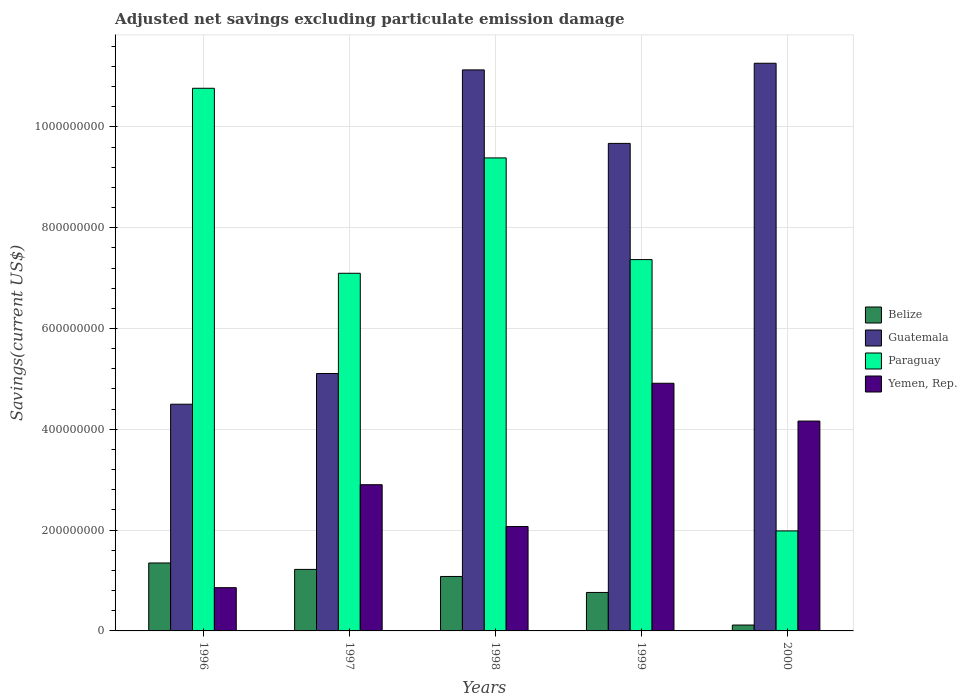How many groups of bars are there?
Offer a terse response. 5. Are the number of bars per tick equal to the number of legend labels?
Offer a terse response. Yes. How many bars are there on the 2nd tick from the left?
Your response must be concise. 4. How many bars are there on the 2nd tick from the right?
Keep it short and to the point. 4. What is the label of the 3rd group of bars from the left?
Keep it short and to the point. 1998. In how many cases, is the number of bars for a given year not equal to the number of legend labels?
Your response must be concise. 0. What is the adjusted net savings in Guatemala in 1999?
Your response must be concise. 9.67e+08. Across all years, what is the maximum adjusted net savings in Paraguay?
Keep it short and to the point. 1.08e+09. Across all years, what is the minimum adjusted net savings in Belize?
Ensure brevity in your answer.  1.17e+07. In which year was the adjusted net savings in Yemen, Rep. maximum?
Make the answer very short. 1999. What is the total adjusted net savings in Belize in the graph?
Keep it short and to the point. 4.53e+08. What is the difference between the adjusted net savings in Guatemala in 1996 and that in 1997?
Your answer should be compact. -6.09e+07. What is the difference between the adjusted net savings in Belize in 1998 and the adjusted net savings in Yemen, Rep. in 1996?
Offer a terse response. 2.22e+07. What is the average adjusted net savings in Guatemala per year?
Provide a succinct answer. 8.33e+08. In the year 2000, what is the difference between the adjusted net savings in Paraguay and adjusted net savings in Yemen, Rep.?
Ensure brevity in your answer.  -2.18e+08. In how many years, is the adjusted net savings in Guatemala greater than 1080000000 US$?
Ensure brevity in your answer.  2. What is the ratio of the adjusted net savings in Guatemala in 1998 to that in 2000?
Your answer should be very brief. 0.99. Is the adjusted net savings in Yemen, Rep. in 1997 less than that in 2000?
Provide a short and direct response. Yes. Is the difference between the adjusted net savings in Paraguay in 1996 and 2000 greater than the difference between the adjusted net savings in Yemen, Rep. in 1996 and 2000?
Make the answer very short. Yes. What is the difference between the highest and the second highest adjusted net savings in Yemen, Rep.?
Provide a succinct answer. 7.50e+07. What is the difference between the highest and the lowest adjusted net savings in Guatemala?
Provide a succinct answer. 6.76e+08. In how many years, is the adjusted net savings in Paraguay greater than the average adjusted net savings in Paraguay taken over all years?
Your response must be concise. 3. Is it the case that in every year, the sum of the adjusted net savings in Guatemala and adjusted net savings in Yemen, Rep. is greater than the sum of adjusted net savings in Belize and adjusted net savings in Paraguay?
Keep it short and to the point. Yes. What does the 3rd bar from the left in 1998 represents?
Your answer should be compact. Paraguay. What does the 2nd bar from the right in 1997 represents?
Provide a succinct answer. Paraguay. Are all the bars in the graph horizontal?
Make the answer very short. No. How many years are there in the graph?
Give a very brief answer. 5. Does the graph contain any zero values?
Your answer should be compact. No. Does the graph contain grids?
Offer a terse response. Yes. Where does the legend appear in the graph?
Make the answer very short. Center right. How are the legend labels stacked?
Give a very brief answer. Vertical. What is the title of the graph?
Provide a short and direct response. Adjusted net savings excluding particulate emission damage. What is the label or title of the X-axis?
Make the answer very short. Years. What is the label or title of the Y-axis?
Make the answer very short. Savings(current US$). What is the Savings(current US$) of Belize in 1996?
Offer a terse response. 1.35e+08. What is the Savings(current US$) in Guatemala in 1996?
Provide a succinct answer. 4.50e+08. What is the Savings(current US$) of Paraguay in 1996?
Provide a short and direct response. 1.08e+09. What is the Savings(current US$) in Yemen, Rep. in 1996?
Make the answer very short. 8.58e+07. What is the Savings(current US$) of Belize in 1997?
Give a very brief answer. 1.22e+08. What is the Savings(current US$) in Guatemala in 1997?
Provide a succinct answer. 5.11e+08. What is the Savings(current US$) in Paraguay in 1997?
Provide a short and direct response. 7.10e+08. What is the Savings(current US$) in Yemen, Rep. in 1997?
Keep it short and to the point. 2.90e+08. What is the Savings(current US$) of Belize in 1998?
Offer a very short reply. 1.08e+08. What is the Savings(current US$) of Guatemala in 1998?
Keep it short and to the point. 1.11e+09. What is the Savings(current US$) in Paraguay in 1998?
Provide a short and direct response. 9.38e+08. What is the Savings(current US$) of Yemen, Rep. in 1998?
Provide a succinct answer. 2.07e+08. What is the Savings(current US$) of Belize in 1999?
Your answer should be compact. 7.63e+07. What is the Savings(current US$) of Guatemala in 1999?
Give a very brief answer. 9.67e+08. What is the Savings(current US$) of Paraguay in 1999?
Provide a succinct answer. 7.37e+08. What is the Savings(current US$) of Yemen, Rep. in 1999?
Provide a succinct answer. 4.91e+08. What is the Savings(current US$) in Belize in 2000?
Offer a terse response. 1.17e+07. What is the Savings(current US$) of Guatemala in 2000?
Your answer should be very brief. 1.13e+09. What is the Savings(current US$) in Paraguay in 2000?
Your answer should be compact. 1.98e+08. What is the Savings(current US$) of Yemen, Rep. in 2000?
Provide a short and direct response. 4.16e+08. Across all years, what is the maximum Savings(current US$) in Belize?
Offer a very short reply. 1.35e+08. Across all years, what is the maximum Savings(current US$) in Guatemala?
Offer a terse response. 1.13e+09. Across all years, what is the maximum Savings(current US$) in Paraguay?
Offer a very short reply. 1.08e+09. Across all years, what is the maximum Savings(current US$) in Yemen, Rep.?
Your response must be concise. 4.91e+08. Across all years, what is the minimum Savings(current US$) in Belize?
Ensure brevity in your answer.  1.17e+07. Across all years, what is the minimum Savings(current US$) of Guatemala?
Ensure brevity in your answer.  4.50e+08. Across all years, what is the minimum Savings(current US$) of Paraguay?
Ensure brevity in your answer.  1.98e+08. Across all years, what is the minimum Savings(current US$) of Yemen, Rep.?
Your answer should be very brief. 8.58e+07. What is the total Savings(current US$) of Belize in the graph?
Make the answer very short. 4.53e+08. What is the total Savings(current US$) in Guatemala in the graph?
Keep it short and to the point. 4.17e+09. What is the total Savings(current US$) in Paraguay in the graph?
Your response must be concise. 3.66e+09. What is the total Savings(current US$) in Yemen, Rep. in the graph?
Provide a succinct answer. 1.49e+09. What is the difference between the Savings(current US$) of Belize in 1996 and that in 1997?
Keep it short and to the point. 1.27e+07. What is the difference between the Savings(current US$) in Guatemala in 1996 and that in 1997?
Keep it short and to the point. -6.09e+07. What is the difference between the Savings(current US$) in Paraguay in 1996 and that in 1997?
Offer a very short reply. 3.67e+08. What is the difference between the Savings(current US$) in Yemen, Rep. in 1996 and that in 1997?
Offer a terse response. -2.04e+08. What is the difference between the Savings(current US$) in Belize in 1996 and that in 1998?
Ensure brevity in your answer.  2.68e+07. What is the difference between the Savings(current US$) in Guatemala in 1996 and that in 1998?
Offer a very short reply. -6.63e+08. What is the difference between the Savings(current US$) of Paraguay in 1996 and that in 1998?
Your response must be concise. 1.38e+08. What is the difference between the Savings(current US$) in Yemen, Rep. in 1996 and that in 1998?
Ensure brevity in your answer.  -1.21e+08. What is the difference between the Savings(current US$) in Belize in 1996 and that in 1999?
Provide a short and direct response. 5.85e+07. What is the difference between the Savings(current US$) of Guatemala in 1996 and that in 1999?
Give a very brief answer. -5.17e+08. What is the difference between the Savings(current US$) of Paraguay in 1996 and that in 1999?
Your answer should be very brief. 3.40e+08. What is the difference between the Savings(current US$) in Yemen, Rep. in 1996 and that in 1999?
Offer a very short reply. -4.06e+08. What is the difference between the Savings(current US$) in Belize in 1996 and that in 2000?
Offer a terse response. 1.23e+08. What is the difference between the Savings(current US$) of Guatemala in 1996 and that in 2000?
Your answer should be compact. -6.76e+08. What is the difference between the Savings(current US$) of Paraguay in 1996 and that in 2000?
Your answer should be very brief. 8.78e+08. What is the difference between the Savings(current US$) of Yemen, Rep. in 1996 and that in 2000?
Ensure brevity in your answer.  -3.31e+08. What is the difference between the Savings(current US$) of Belize in 1997 and that in 1998?
Provide a short and direct response. 1.40e+07. What is the difference between the Savings(current US$) in Guatemala in 1997 and that in 1998?
Your answer should be compact. -6.02e+08. What is the difference between the Savings(current US$) of Paraguay in 1997 and that in 1998?
Keep it short and to the point. -2.29e+08. What is the difference between the Savings(current US$) in Yemen, Rep. in 1997 and that in 1998?
Keep it short and to the point. 8.30e+07. What is the difference between the Savings(current US$) in Belize in 1997 and that in 1999?
Keep it short and to the point. 4.57e+07. What is the difference between the Savings(current US$) of Guatemala in 1997 and that in 1999?
Your answer should be compact. -4.57e+08. What is the difference between the Savings(current US$) of Paraguay in 1997 and that in 1999?
Offer a terse response. -2.71e+07. What is the difference between the Savings(current US$) of Yemen, Rep. in 1997 and that in 1999?
Ensure brevity in your answer.  -2.01e+08. What is the difference between the Savings(current US$) of Belize in 1997 and that in 2000?
Your answer should be very brief. 1.10e+08. What is the difference between the Savings(current US$) of Guatemala in 1997 and that in 2000?
Give a very brief answer. -6.16e+08. What is the difference between the Savings(current US$) of Paraguay in 1997 and that in 2000?
Your answer should be very brief. 5.11e+08. What is the difference between the Savings(current US$) of Yemen, Rep. in 1997 and that in 2000?
Your answer should be very brief. -1.26e+08. What is the difference between the Savings(current US$) in Belize in 1998 and that in 1999?
Provide a short and direct response. 3.17e+07. What is the difference between the Savings(current US$) of Guatemala in 1998 and that in 1999?
Your answer should be compact. 1.46e+08. What is the difference between the Savings(current US$) of Paraguay in 1998 and that in 1999?
Offer a terse response. 2.02e+08. What is the difference between the Savings(current US$) of Yemen, Rep. in 1998 and that in 1999?
Make the answer very short. -2.84e+08. What is the difference between the Savings(current US$) of Belize in 1998 and that in 2000?
Your response must be concise. 9.64e+07. What is the difference between the Savings(current US$) in Guatemala in 1998 and that in 2000?
Offer a terse response. -1.32e+07. What is the difference between the Savings(current US$) of Paraguay in 1998 and that in 2000?
Your answer should be compact. 7.40e+08. What is the difference between the Savings(current US$) in Yemen, Rep. in 1998 and that in 2000?
Provide a succinct answer. -2.09e+08. What is the difference between the Savings(current US$) in Belize in 1999 and that in 2000?
Your answer should be compact. 6.47e+07. What is the difference between the Savings(current US$) in Guatemala in 1999 and that in 2000?
Make the answer very short. -1.59e+08. What is the difference between the Savings(current US$) in Paraguay in 1999 and that in 2000?
Your answer should be compact. 5.38e+08. What is the difference between the Savings(current US$) in Yemen, Rep. in 1999 and that in 2000?
Your answer should be compact. 7.50e+07. What is the difference between the Savings(current US$) of Belize in 1996 and the Savings(current US$) of Guatemala in 1997?
Offer a very short reply. -3.76e+08. What is the difference between the Savings(current US$) of Belize in 1996 and the Savings(current US$) of Paraguay in 1997?
Your response must be concise. -5.75e+08. What is the difference between the Savings(current US$) of Belize in 1996 and the Savings(current US$) of Yemen, Rep. in 1997?
Your response must be concise. -1.55e+08. What is the difference between the Savings(current US$) in Guatemala in 1996 and the Savings(current US$) in Paraguay in 1997?
Keep it short and to the point. -2.60e+08. What is the difference between the Savings(current US$) of Guatemala in 1996 and the Savings(current US$) of Yemen, Rep. in 1997?
Offer a very short reply. 1.60e+08. What is the difference between the Savings(current US$) in Paraguay in 1996 and the Savings(current US$) in Yemen, Rep. in 1997?
Keep it short and to the point. 7.87e+08. What is the difference between the Savings(current US$) of Belize in 1996 and the Savings(current US$) of Guatemala in 1998?
Give a very brief answer. -9.78e+08. What is the difference between the Savings(current US$) of Belize in 1996 and the Savings(current US$) of Paraguay in 1998?
Offer a very short reply. -8.04e+08. What is the difference between the Savings(current US$) of Belize in 1996 and the Savings(current US$) of Yemen, Rep. in 1998?
Your answer should be very brief. -7.23e+07. What is the difference between the Savings(current US$) of Guatemala in 1996 and the Savings(current US$) of Paraguay in 1998?
Provide a succinct answer. -4.89e+08. What is the difference between the Savings(current US$) in Guatemala in 1996 and the Savings(current US$) in Yemen, Rep. in 1998?
Ensure brevity in your answer.  2.43e+08. What is the difference between the Savings(current US$) of Paraguay in 1996 and the Savings(current US$) of Yemen, Rep. in 1998?
Your answer should be compact. 8.70e+08. What is the difference between the Savings(current US$) of Belize in 1996 and the Savings(current US$) of Guatemala in 1999?
Give a very brief answer. -8.32e+08. What is the difference between the Savings(current US$) of Belize in 1996 and the Savings(current US$) of Paraguay in 1999?
Your response must be concise. -6.02e+08. What is the difference between the Savings(current US$) of Belize in 1996 and the Savings(current US$) of Yemen, Rep. in 1999?
Your answer should be very brief. -3.57e+08. What is the difference between the Savings(current US$) in Guatemala in 1996 and the Savings(current US$) in Paraguay in 1999?
Your response must be concise. -2.87e+08. What is the difference between the Savings(current US$) in Guatemala in 1996 and the Savings(current US$) in Yemen, Rep. in 1999?
Ensure brevity in your answer.  -4.16e+07. What is the difference between the Savings(current US$) of Paraguay in 1996 and the Savings(current US$) of Yemen, Rep. in 1999?
Provide a succinct answer. 5.85e+08. What is the difference between the Savings(current US$) in Belize in 1996 and the Savings(current US$) in Guatemala in 2000?
Offer a very short reply. -9.91e+08. What is the difference between the Savings(current US$) in Belize in 1996 and the Savings(current US$) in Paraguay in 2000?
Keep it short and to the point. -6.36e+07. What is the difference between the Savings(current US$) of Belize in 1996 and the Savings(current US$) of Yemen, Rep. in 2000?
Keep it short and to the point. -2.82e+08. What is the difference between the Savings(current US$) of Guatemala in 1996 and the Savings(current US$) of Paraguay in 2000?
Provide a short and direct response. 2.51e+08. What is the difference between the Savings(current US$) of Guatemala in 1996 and the Savings(current US$) of Yemen, Rep. in 2000?
Keep it short and to the point. 3.34e+07. What is the difference between the Savings(current US$) of Paraguay in 1996 and the Savings(current US$) of Yemen, Rep. in 2000?
Offer a very short reply. 6.60e+08. What is the difference between the Savings(current US$) in Belize in 1997 and the Savings(current US$) in Guatemala in 1998?
Provide a succinct answer. -9.91e+08. What is the difference between the Savings(current US$) of Belize in 1997 and the Savings(current US$) of Paraguay in 1998?
Provide a succinct answer. -8.16e+08. What is the difference between the Savings(current US$) in Belize in 1997 and the Savings(current US$) in Yemen, Rep. in 1998?
Your answer should be compact. -8.50e+07. What is the difference between the Savings(current US$) in Guatemala in 1997 and the Savings(current US$) in Paraguay in 1998?
Your answer should be very brief. -4.28e+08. What is the difference between the Savings(current US$) of Guatemala in 1997 and the Savings(current US$) of Yemen, Rep. in 1998?
Provide a short and direct response. 3.04e+08. What is the difference between the Savings(current US$) in Paraguay in 1997 and the Savings(current US$) in Yemen, Rep. in 1998?
Offer a very short reply. 5.02e+08. What is the difference between the Savings(current US$) in Belize in 1997 and the Savings(current US$) in Guatemala in 1999?
Your response must be concise. -8.45e+08. What is the difference between the Savings(current US$) of Belize in 1997 and the Savings(current US$) of Paraguay in 1999?
Your answer should be very brief. -6.15e+08. What is the difference between the Savings(current US$) of Belize in 1997 and the Savings(current US$) of Yemen, Rep. in 1999?
Your answer should be very brief. -3.69e+08. What is the difference between the Savings(current US$) of Guatemala in 1997 and the Savings(current US$) of Paraguay in 1999?
Your response must be concise. -2.26e+08. What is the difference between the Savings(current US$) of Guatemala in 1997 and the Savings(current US$) of Yemen, Rep. in 1999?
Give a very brief answer. 1.93e+07. What is the difference between the Savings(current US$) in Paraguay in 1997 and the Savings(current US$) in Yemen, Rep. in 1999?
Offer a terse response. 2.18e+08. What is the difference between the Savings(current US$) of Belize in 1997 and the Savings(current US$) of Guatemala in 2000?
Your answer should be compact. -1.00e+09. What is the difference between the Savings(current US$) in Belize in 1997 and the Savings(current US$) in Paraguay in 2000?
Offer a very short reply. -7.64e+07. What is the difference between the Savings(current US$) in Belize in 1997 and the Savings(current US$) in Yemen, Rep. in 2000?
Provide a short and direct response. -2.94e+08. What is the difference between the Savings(current US$) in Guatemala in 1997 and the Savings(current US$) in Paraguay in 2000?
Provide a succinct answer. 3.12e+08. What is the difference between the Savings(current US$) in Guatemala in 1997 and the Savings(current US$) in Yemen, Rep. in 2000?
Ensure brevity in your answer.  9.43e+07. What is the difference between the Savings(current US$) in Paraguay in 1997 and the Savings(current US$) in Yemen, Rep. in 2000?
Provide a short and direct response. 2.93e+08. What is the difference between the Savings(current US$) in Belize in 1998 and the Savings(current US$) in Guatemala in 1999?
Give a very brief answer. -8.59e+08. What is the difference between the Savings(current US$) in Belize in 1998 and the Savings(current US$) in Paraguay in 1999?
Provide a succinct answer. -6.29e+08. What is the difference between the Savings(current US$) of Belize in 1998 and the Savings(current US$) of Yemen, Rep. in 1999?
Your answer should be very brief. -3.83e+08. What is the difference between the Savings(current US$) of Guatemala in 1998 and the Savings(current US$) of Paraguay in 1999?
Give a very brief answer. 3.76e+08. What is the difference between the Savings(current US$) of Guatemala in 1998 and the Savings(current US$) of Yemen, Rep. in 1999?
Keep it short and to the point. 6.22e+08. What is the difference between the Savings(current US$) of Paraguay in 1998 and the Savings(current US$) of Yemen, Rep. in 1999?
Keep it short and to the point. 4.47e+08. What is the difference between the Savings(current US$) in Belize in 1998 and the Savings(current US$) in Guatemala in 2000?
Offer a very short reply. -1.02e+09. What is the difference between the Savings(current US$) of Belize in 1998 and the Savings(current US$) of Paraguay in 2000?
Give a very brief answer. -9.04e+07. What is the difference between the Savings(current US$) of Belize in 1998 and the Savings(current US$) of Yemen, Rep. in 2000?
Make the answer very short. -3.08e+08. What is the difference between the Savings(current US$) of Guatemala in 1998 and the Savings(current US$) of Paraguay in 2000?
Your answer should be very brief. 9.15e+08. What is the difference between the Savings(current US$) in Guatemala in 1998 and the Savings(current US$) in Yemen, Rep. in 2000?
Your answer should be compact. 6.97e+08. What is the difference between the Savings(current US$) in Paraguay in 1998 and the Savings(current US$) in Yemen, Rep. in 2000?
Provide a short and direct response. 5.22e+08. What is the difference between the Savings(current US$) of Belize in 1999 and the Savings(current US$) of Guatemala in 2000?
Your answer should be compact. -1.05e+09. What is the difference between the Savings(current US$) of Belize in 1999 and the Savings(current US$) of Paraguay in 2000?
Provide a short and direct response. -1.22e+08. What is the difference between the Savings(current US$) in Belize in 1999 and the Savings(current US$) in Yemen, Rep. in 2000?
Make the answer very short. -3.40e+08. What is the difference between the Savings(current US$) of Guatemala in 1999 and the Savings(current US$) of Paraguay in 2000?
Your response must be concise. 7.69e+08. What is the difference between the Savings(current US$) of Guatemala in 1999 and the Savings(current US$) of Yemen, Rep. in 2000?
Provide a succinct answer. 5.51e+08. What is the difference between the Savings(current US$) in Paraguay in 1999 and the Savings(current US$) in Yemen, Rep. in 2000?
Your answer should be very brief. 3.20e+08. What is the average Savings(current US$) of Belize per year?
Ensure brevity in your answer.  9.06e+07. What is the average Savings(current US$) of Guatemala per year?
Your answer should be compact. 8.33e+08. What is the average Savings(current US$) of Paraguay per year?
Make the answer very short. 7.32e+08. What is the average Savings(current US$) of Yemen, Rep. per year?
Your answer should be very brief. 2.98e+08. In the year 1996, what is the difference between the Savings(current US$) of Belize and Savings(current US$) of Guatemala?
Your answer should be very brief. -3.15e+08. In the year 1996, what is the difference between the Savings(current US$) in Belize and Savings(current US$) in Paraguay?
Your answer should be very brief. -9.42e+08. In the year 1996, what is the difference between the Savings(current US$) in Belize and Savings(current US$) in Yemen, Rep.?
Provide a short and direct response. 4.90e+07. In the year 1996, what is the difference between the Savings(current US$) of Guatemala and Savings(current US$) of Paraguay?
Provide a succinct answer. -6.27e+08. In the year 1996, what is the difference between the Savings(current US$) of Guatemala and Savings(current US$) of Yemen, Rep.?
Offer a very short reply. 3.64e+08. In the year 1996, what is the difference between the Savings(current US$) in Paraguay and Savings(current US$) in Yemen, Rep.?
Ensure brevity in your answer.  9.91e+08. In the year 1997, what is the difference between the Savings(current US$) of Belize and Savings(current US$) of Guatemala?
Give a very brief answer. -3.89e+08. In the year 1997, what is the difference between the Savings(current US$) in Belize and Savings(current US$) in Paraguay?
Keep it short and to the point. -5.88e+08. In the year 1997, what is the difference between the Savings(current US$) of Belize and Savings(current US$) of Yemen, Rep.?
Provide a short and direct response. -1.68e+08. In the year 1997, what is the difference between the Savings(current US$) in Guatemala and Savings(current US$) in Paraguay?
Ensure brevity in your answer.  -1.99e+08. In the year 1997, what is the difference between the Savings(current US$) in Guatemala and Savings(current US$) in Yemen, Rep.?
Keep it short and to the point. 2.21e+08. In the year 1997, what is the difference between the Savings(current US$) in Paraguay and Savings(current US$) in Yemen, Rep.?
Provide a short and direct response. 4.20e+08. In the year 1998, what is the difference between the Savings(current US$) in Belize and Savings(current US$) in Guatemala?
Your answer should be compact. -1.01e+09. In the year 1998, what is the difference between the Savings(current US$) of Belize and Savings(current US$) of Paraguay?
Provide a short and direct response. -8.30e+08. In the year 1998, what is the difference between the Savings(current US$) of Belize and Savings(current US$) of Yemen, Rep.?
Keep it short and to the point. -9.91e+07. In the year 1998, what is the difference between the Savings(current US$) in Guatemala and Savings(current US$) in Paraguay?
Offer a very short reply. 1.75e+08. In the year 1998, what is the difference between the Savings(current US$) of Guatemala and Savings(current US$) of Yemen, Rep.?
Offer a terse response. 9.06e+08. In the year 1998, what is the difference between the Savings(current US$) of Paraguay and Savings(current US$) of Yemen, Rep.?
Provide a succinct answer. 7.31e+08. In the year 1999, what is the difference between the Savings(current US$) in Belize and Savings(current US$) in Guatemala?
Offer a terse response. -8.91e+08. In the year 1999, what is the difference between the Savings(current US$) of Belize and Savings(current US$) of Paraguay?
Offer a terse response. -6.60e+08. In the year 1999, what is the difference between the Savings(current US$) in Belize and Savings(current US$) in Yemen, Rep.?
Ensure brevity in your answer.  -4.15e+08. In the year 1999, what is the difference between the Savings(current US$) of Guatemala and Savings(current US$) of Paraguay?
Offer a very short reply. 2.31e+08. In the year 1999, what is the difference between the Savings(current US$) in Guatemala and Savings(current US$) in Yemen, Rep.?
Offer a terse response. 4.76e+08. In the year 1999, what is the difference between the Savings(current US$) of Paraguay and Savings(current US$) of Yemen, Rep.?
Your answer should be compact. 2.45e+08. In the year 2000, what is the difference between the Savings(current US$) of Belize and Savings(current US$) of Guatemala?
Offer a terse response. -1.11e+09. In the year 2000, what is the difference between the Savings(current US$) of Belize and Savings(current US$) of Paraguay?
Ensure brevity in your answer.  -1.87e+08. In the year 2000, what is the difference between the Savings(current US$) in Belize and Savings(current US$) in Yemen, Rep.?
Offer a very short reply. -4.05e+08. In the year 2000, what is the difference between the Savings(current US$) in Guatemala and Savings(current US$) in Paraguay?
Make the answer very short. 9.28e+08. In the year 2000, what is the difference between the Savings(current US$) of Guatemala and Savings(current US$) of Yemen, Rep.?
Keep it short and to the point. 7.10e+08. In the year 2000, what is the difference between the Savings(current US$) of Paraguay and Savings(current US$) of Yemen, Rep.?
Your answer should be compact. -2.18e+08. What is the ratio of the Savings(current US$) of Belize in 1996 to that in 1997?
Ensure brevity in your answer.  1.1. What is the ratio of the Savings(current US$) of Guatemala in 1996 to that in 1997?
Offer a terse response. 0.88. What is the ratio of the Savings(current US$) of Paraguay in 1996 to that in 1997?
Your answer should be compact. 1.52. What is the ratio of the Savings(current US$) in Yemen, Rep. in 1996 to that in 1997?
Keep it short and to the point. 0.3. What is the ratio of the Savings(current US$) of Belize in 1996 to that in 1998?
Give a very brief answer. 1.25. What is the ratio of the Savings(current US$) of Guatemala in 1996 to that in 1998?
Your response must be concise. 0.4. What is the ratio of the Savings(current US$) in Paraguay in 1996 to that in 1998?
Your answer should be very brief. 1.15. What is the ratio of the Savings(current US$) of Yemen, Rep. in 1996 to that in 1998?
Offer a very short reply. 0.41. What is the ratio of the Savings(current US$) of Belize in 1996 to that in 1999?
Give a very brief answer. 1.77. What is the ratio of the Savings(current US$) in Guatemala in 1996 to that in 1999?
Your answer should be compact. 0.47. What is the ratio of the Savings(current US$) of Paraguay in 1996 to that in 1999?
Your response must be concise. 1.46. What is the ratio of the Savings(current US$) in Yemen, Rep. in 1996 to that in 1999?
Give a very brief answer. 0.17. What is the ratio of the Savings(current US$) of Belize in 1996 to that in 2000?
Offer a terse response. 11.54. What is the ratio of the Savings(current US$) in Guatemala in 1996 to that in 2000?
Make the answer very short. 0.4. What is the ratio of the Savings(current US$) of Paraguay in 1996 to that in 2000?
Provide a succinct answer. 5.43. What is the ratio of the Savings(current US$) of Yemen, Rep. in 1996 to that in 2000?
Offer a terse response. 0.21. What is the ratio of the Savings(current US$) of Belize in 1997 to that in 1998?
Make the answer very short. 1.13. What is the ratio of the Savings(current US$) of Guatemala in 1997 to that in 1998?
Keep it short and to the point. 0.46. What is the ratio of the Savings(current US$) in Paraguay in 1997 to that in 1998?
Your response must be concise. 0.76. What is the ratio of the Savings(current US$) in Yemen, Rep. in 1997 to that in 1998?
Give a very brief answer. 1.4. What is the ratio of the Savings(current US$) in Belize in 1997 to that in 1999?
Give a very brief answer. 1.6. What is the ratio of the Savings(current US$) in Guatemala in 1997 to that in 1999?
Offer a very short reply. 0.53. What is the ratio of the Savings(current US$) in Paraguay in 1997 to that in 1999?
Keep it short and to the point. 0.96. What is the ratio of the Savings(current US$) of Yemen, Rep. in 1997 to that in 1999?
Offer a terse response. 0.59. What is the ratio of the Savings(current US$) in Belize in 1997 to that in 2000?
Your response must be concise. 10.45. What is the ratio of the Savings(current US$) of Guatemala in 1997 to that in 2000?
Make the answer very short. 0.45. What is the ratio of the Savings(current US$) in Paraguay in 1997 to that in 2000?
Provide a succinct answer. 3.58. What is the ratio of the Savings(current US$) of Yemen, Rep. in 1997 to that in 2000?
Offer a very short reply. 0.7. What is the ratio of the Savings(current US$) in Belize in 1998 to that in 1999?
Ensure brevity in your answer.  1.42. What is the ratio of the Savings(current US$) of Guatemala in 1998 to that in 1999?
Ensure brevity in your answer.  1.15. What is the ratio of the Savings(current US$) in Paraguay in 1998 to that in 1999?
Provide a short and direct response. 1.27. What is the ratio of the Savings(current US$) in Yemen, Rep. in 1998 to that in 1999?
Offer a terse response. 0.42. What is the ratio of the Savings(current US$) of Belize in 1998 to that in 2000?
Your response must be concise. 9.25. What is the ratio of the Savings(current US$) of Guatemala in 1998 to that in 2000?
Provide a short and direct response. 0.99. What is the ratio of the Savings(current US$) of Paraguay in 1998 to that in 2000?
Your answer should be very brief. 4.73. What is the ratio of the Savings(current US$) of Yemen, Rep. in 1998 to that in 2000?
Offer a terse response. 0.5. What is the ratio of the Savings(current US$) in Belize in 1999 to that in 2000?
Offer a terse response. 6.53. What is the ratio of the Savings(current US$) of Guatemala in 1999 to that in 2000?
Your answer should be very brief. 0.86. What is the ratio of the Savings(current US$) of Paraguay in 1999 to that in 2000?
Offer a terse response. 3.71. What is the ratio of the Savings(current US$) in Yemen, Rep. in 1999 to that in 2000?
Provide a succinct answer. 1.18. What is the difference between the highest and the second highest Savings(current US$) of Belize?
Offer a very short reply. 1.27e+07. What is the difference between the highest and the second highest Savings(current US$) of Guatemala?
Your answer should be compact. 1.32e+07. What is the difference between the highest and the second highest Savings(current US$) in Paraguay?
Keep it short and to the point. 1.38e+08. What is the difference between the highest and the second highest Savings(current US$) in Yemen, Rep.?
Provide a succinct answer. 7.50e+07. What is the difference between the highest and the lowest Savings(current US$) in Belize?
Your response must be concise. 1.23e+08. What is the difference between the highest and the lowest Savings(current US$) in Guatemala?
Provide a short and direct response. 6.76e+08. What is the difference between the highest and the lowest Savings(current US$) of Paraguay?
Your answer should be compact. 8.78e+08. What is the difference between the highest and the lowest Savings(current US$) of Yemen, Rep.?
Provide a short and direct response. 4.06e+08. 